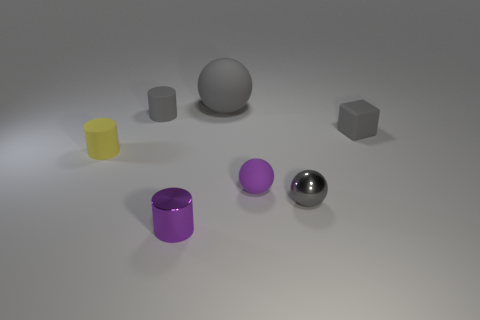Is there any other thing that has the same size as the gray matte ball?
Provide a short and direct response. No. Is the purple shiny object the same size as the yellow rubber cylinder?
Make the answer very short. Yes. How many things are tiny purple metal things or tiny rubber things that are on the left side of the gray matte cube?
Ensure brevity in your answer.  4. Are there fewer small purple spheres in front of the tiny purple metal cylinder than gray rubber cubes left of the gray matte block?
Offer a terse response. No. What number of other objects are the same material as the cube?
Give a very brief answer. 4. Do the cylinder that is on the right side of the gray rubber cylinder and the small matte sphere have the same color?
Your answer should be compact. Yes. Are there any matte spheres that are on the left side of the gray sphere in front of the yellow cylinder?
Your response must be concise. Yes. What is the material of the tiny object that is both in front of the tiny matte sphere and left of the tiny gray metallic ball?
Keep it short and to the point. Metal. The big gray thing that is made of the same material as the yellow thing is what shape?
Your response must be concise. Sphere. Does the gray object left of the small purple cylinder have the same material as the small gray ball?
Your answer should be very brief. No. 